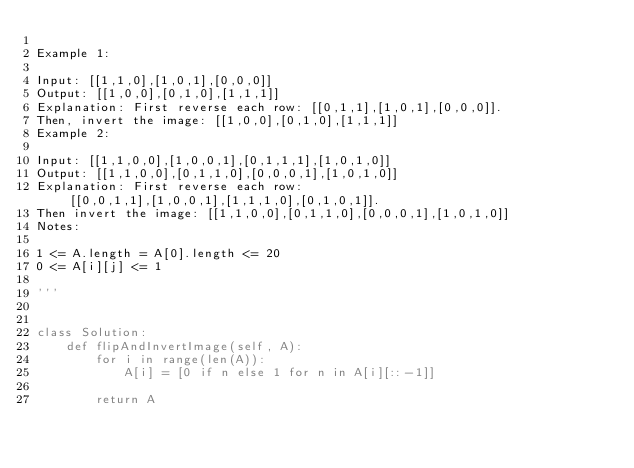Convert code to text. <code><loc_0><loc_0><loc_500><loc_500><_Python_>
Example 1:

Input: [[1,1,0],[1,0,1],[0,0,0]]
Output: [[1,0,0],[0,1,0],[1,1,1]]
Explanation: First reverse each row: [[0,1,1],[1,0,1],[0,0,0]].
Then, invert the image: [[1,0,0],[0,1,0],[1,1,1]]
Example 2:

Input: [[1,1,0,0],[1,0,0,1],[0,1,1,1],[1,0,1,0]]
Output: [[1,1,0,0],[0,1,1,0],[0,0,0,1],[1,0,1,0]]
Explanation: First reverse each row: [[0,0,1,1],[1,0,0,1],[1,1,1,0],[0,1,0,1]].
Then invert the image: [[1,1,0,0],[0,1,1,0],[0,0,0,1],[1,0,1,0]]
Notes:

1 <= A.length = A[0].length <= 20
0 <= A[i][j] <= 1

'''


class Solution:
    def flipAndInvertImage(self, A):
        for i in range(len(A)):
            A[i] = [0 if n else 1 for n in A[i][::-1]]

        return A
</code> 